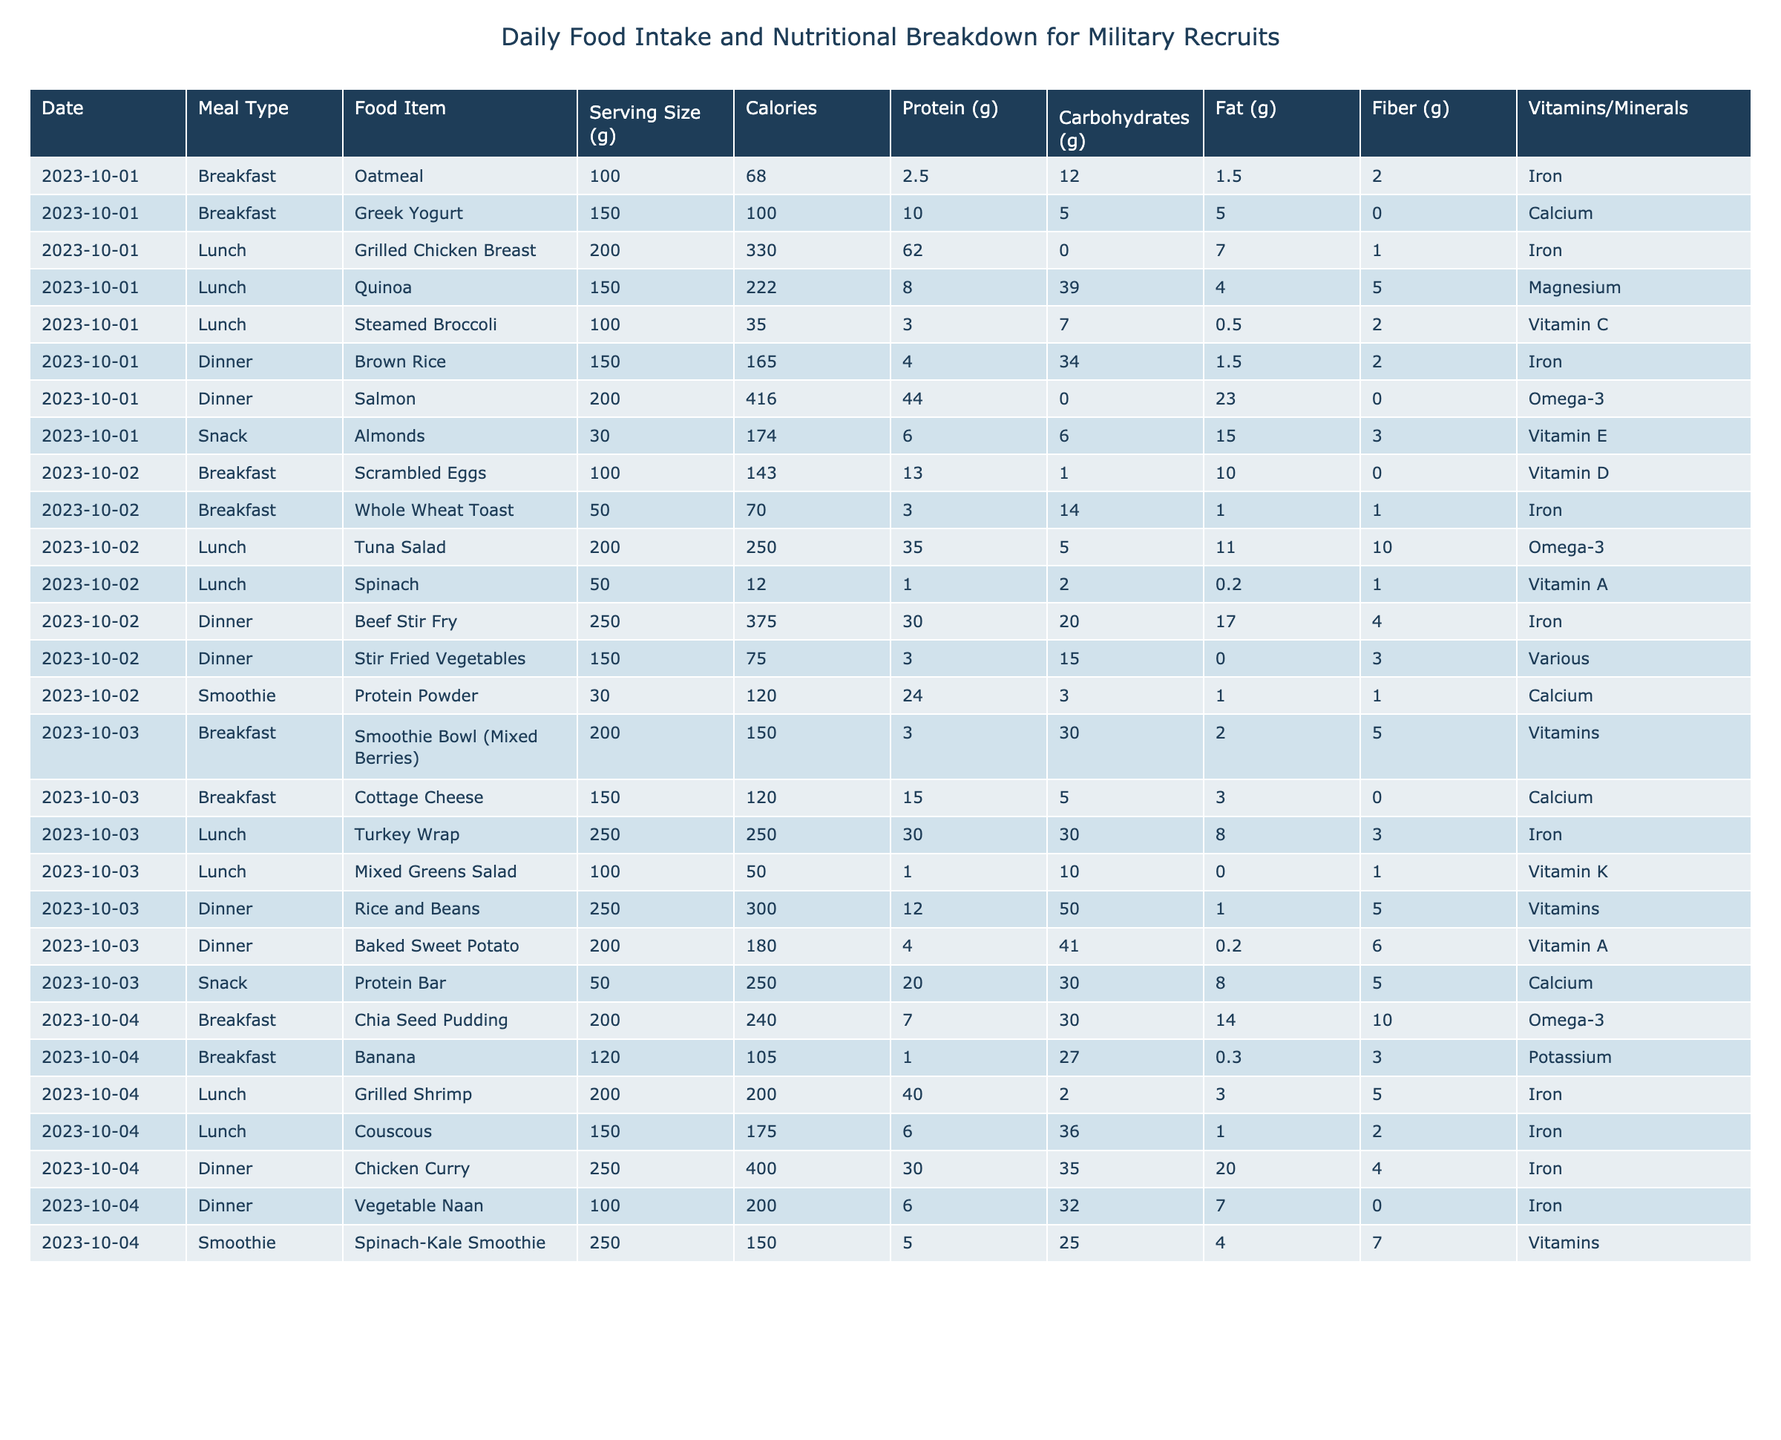What is the total calorie intake for breakfast on October 1st, 2023? The breakfast items for that date are oatmeal (68 calories) and Greek yogurt (100 calories). Adding these gives 68 + 100 = 168.
Answer: 168 Which meal on October 2nd provides the highest protein content? For October 2nd, breakfast has scrambled eggs (13g protein) and whole wheat toast (3g protein), lunch has tuna salad (35g protein) and spinach (1g protein), and dinner has beef stir fry (30g protein) and stir fried vegetables (3g protein). Tuna salad has the highest with 35g.
Answer: Tuna Salad What is the serving size of the almonds consumed as a snack on October 1st? The table indicates that the serving size of almonds is 30 grams.
Answer: 30 grams How many total grams of carbohydrates are consumed in lunch on October 4th? In lunch on October 4th, grilled shrimp has 2g carbohydrates and couscous has 36g. Therefore, total carbohydrates are 2 + 36 = 38g.
Answer: 38g Is there a dinner option on October 3rd that contains Vitamin A? On October 3rd, the dinner options are rice and beans and baked sweet potato, with baked sweet potato containing Vitamin A.
Answer: Yes What is the average number of calories consumed per meal on October 1st? On October 1st, there are three meals (breakfast, lunch, and dinner) with total calories of 68 (oatmeal) + 100 (Greek yogurt) + 330 (chicken) + 222 (quinoa) + 35 (broccoli) + 165 (brown rice) + 416 (salmon) = 1336. Dividing by 3 gives an average of 1336 / 3 ≈ 445.33.
Answer: 445.33 Which food item had the highest fat content on October 4th? The food items on October 4th are chia seed pudding (10g fat), banana (0.3g fat), grilled shrimp (5g fat), couscous (1g fat), chicken curry (20g fat), and vegetable naan (7g fat). Chicken curry has the highest at 20g.
Answer: Chicken Curry How does the total fiber content of breakfast on October 2nd compare to October 4th? On October 2nd, breakfast has scrambled eggs (0g fiber) and whole wheat toast (1g fiber) totaling 1g. On October 4th, breakfast has chia seed pudding (10g fiber) and banana (3g fiber) totaling 13g. Thus, October 4th has more fiber.
Answer: October 4th has more fiber What is the total intake of calories from all snacks throughout the recorded days? The snacks logged are almonds (174 calories on October 1st), protein bar (250 calories on October 3rd), and there are no recorded snacks for the other days. Adding these gives total calories of 174 + 250 = 424 calories.
Answer: 424 calories On which date is the largest serving size for any food item recorded? Reviewing the data, the largest serving size is for beef stir fry on October 2nd at 250g.
Answer: October 2nd 